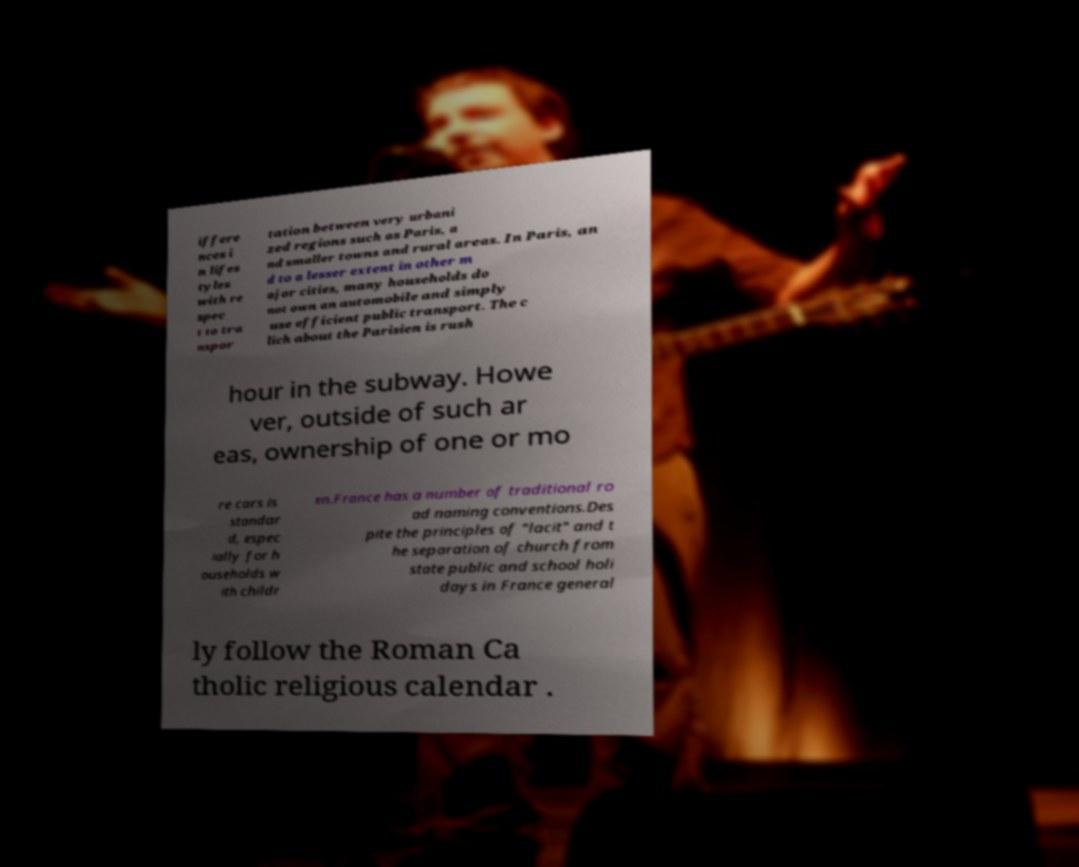What messages or text are displayed in this image? I need them in a readable, typed format. iffere nces i n lifes tyles with re spec t to tra nspor tation between very urbani zed regions such as Paris, a nd smaller towns and rural areas. In Paris, an d to a lesser extent in other m ajor cities, many households do not own an automobile and simply use efficient public transport. The c lich about the Parisien is rush hour in the subway. Howe ver, outside of such ar eas, ownership of one or mo re cars is standar d, espec ially for h ouseholds w ith childr en.France has a number of traditional ro ad naming conventions.Des pite the principles of "lacit" and t he separation of church from state public and school holi days in France general ly follow the Roman Ca tholic religious calendar . 